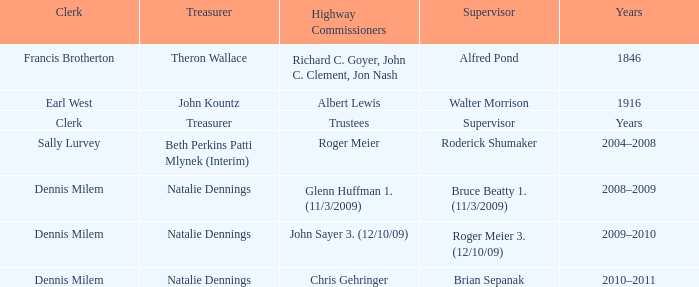When Treasurer was treasurer, who was the highway commissioner? Trustees. 